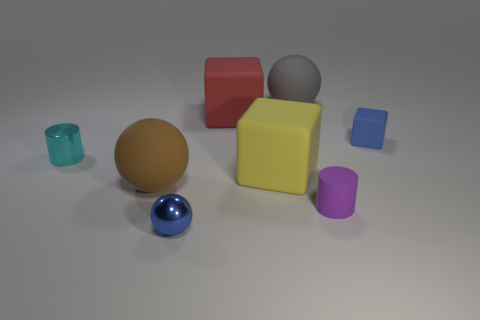Add 2 cylinders. How many objects exist? 10 Subtract all cubes. How many objects are left? 5 Subtract all tiny purple rubber objects. Subtract all large rubber things. How many objects are left? 3 Add 7 cyan metal cylinders. How many cyan metal cylinders are left? 8 Add 3 small green balls. How many small green balls exist? 3 Subtract 0 green spheres. How many objects are left? 8 